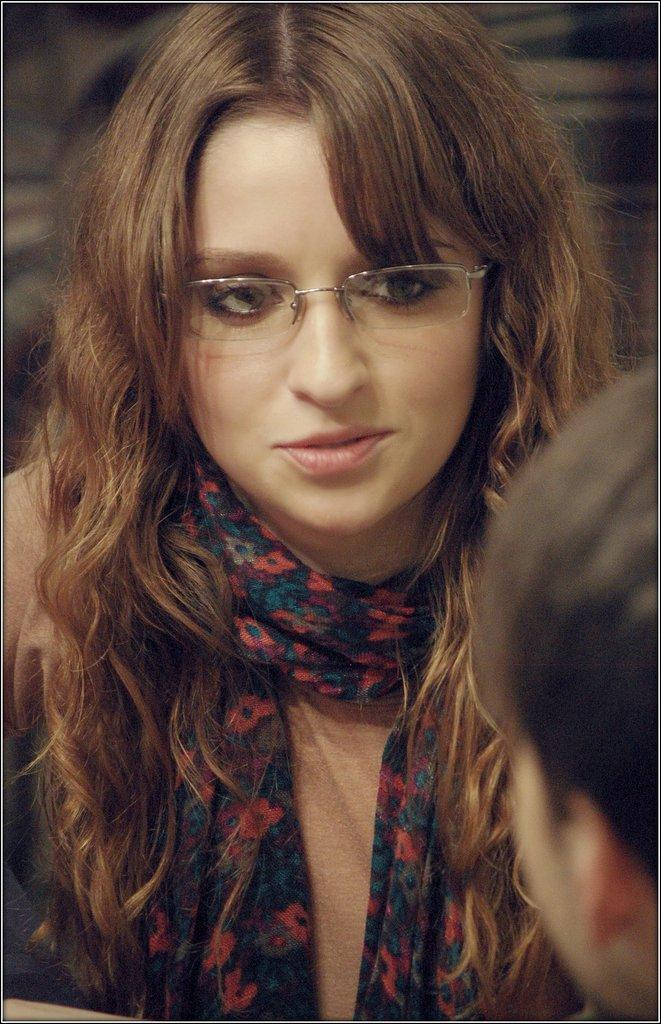Who is the main subject in the image? There is a woman in the image. What is the woman wearing on her face? The woman is wearing spectacles. What is the woman wearing around her neck? The woman is wearing a scarf. What is the woman's facial expression in the image? The woman is smiling. Can you describe the person in front of the woman? Unfortunately, the provided facts do not give any information about the person in front of the woman. What type of grain can be seen growing in the background of the image? There is no grain visible in the image; it features a woman wearing spectacles and a scarf, smiling, with a person in front of her. 